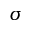<formula> <loc_0><loc_0><loc_500><loc_500>\sigma</formula> 